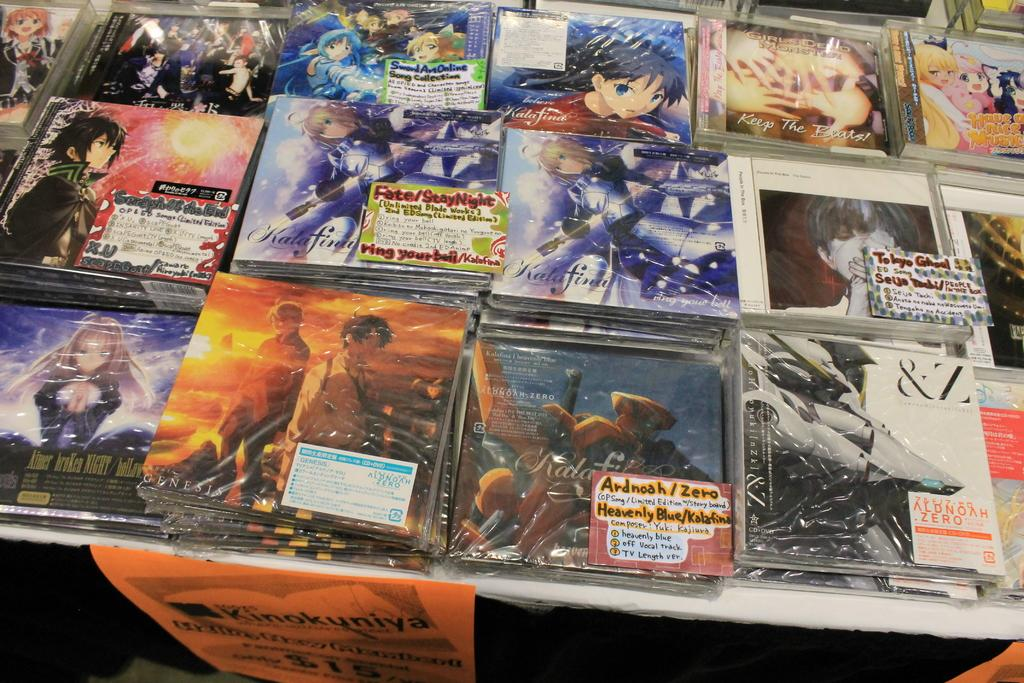<image>
Create a compact narrative representing the image presented. A display of anime on a table, the words Tokyo Ghoul can be seen. 